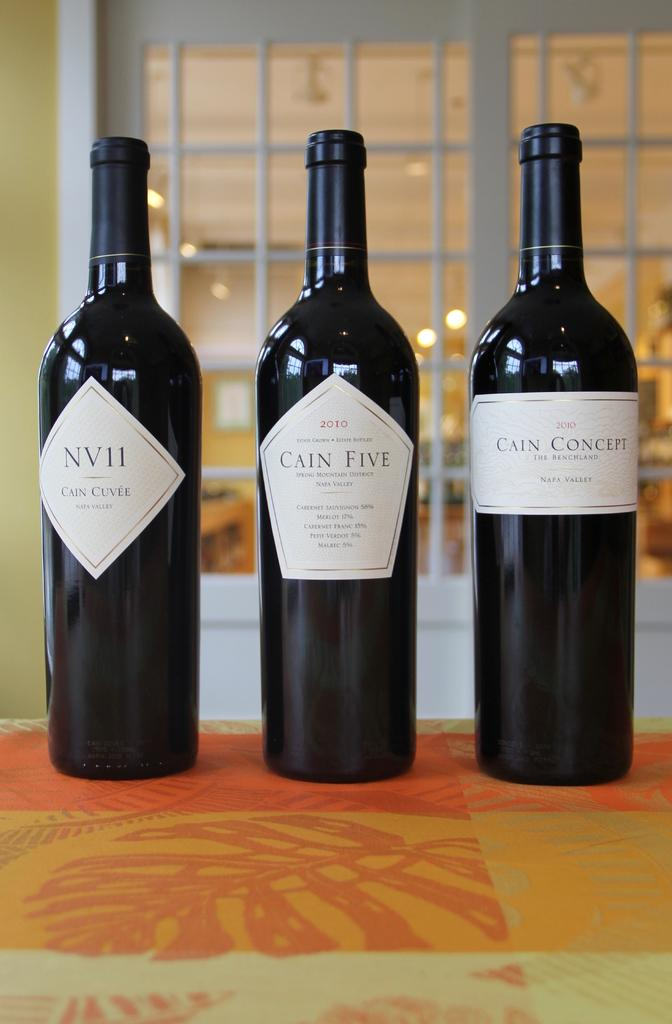<image>
Give a short and clear explanation of the subsequent image. Wine labels give information about the alcohol % and type of wine that is in the bottle. 